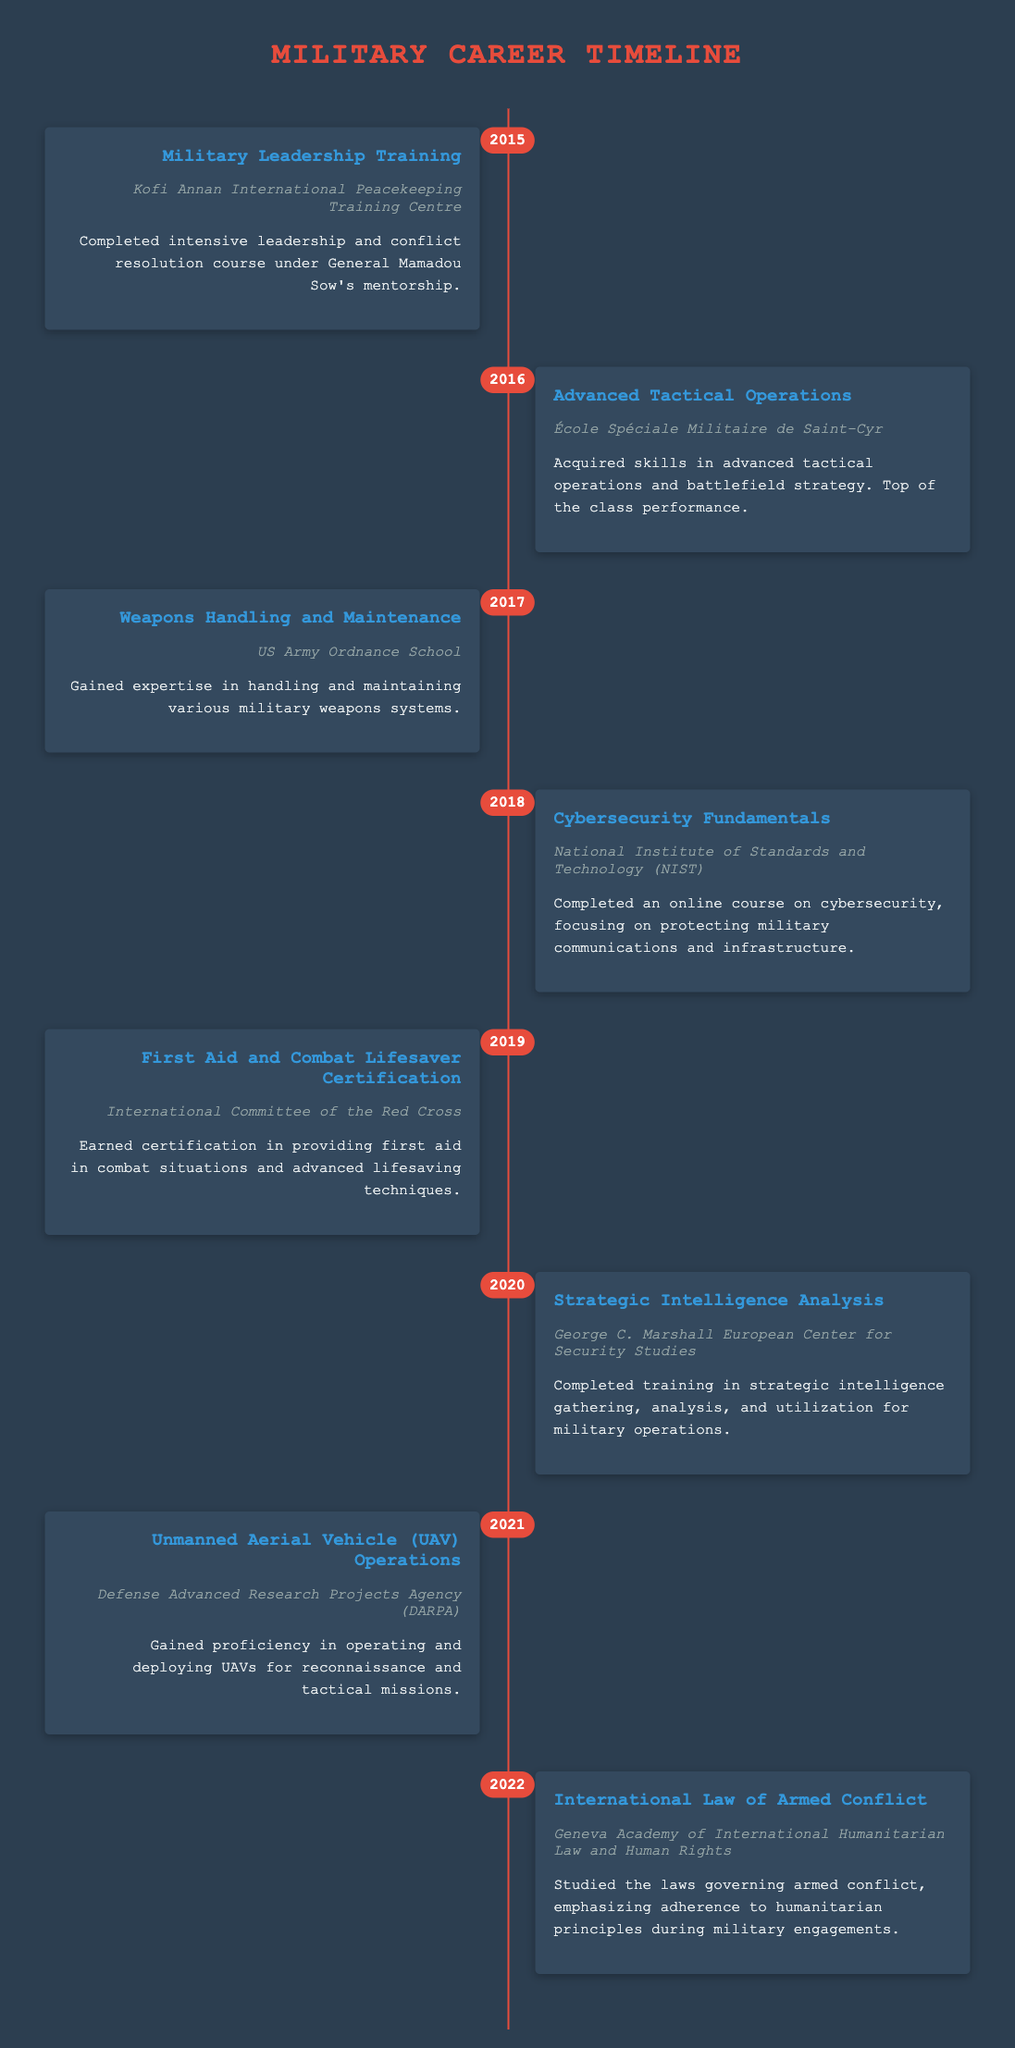What course was completed in 2015? The document states that "Military Leadership Training" was completed in 2015.
Answer: Military Leadership Training Which institution offered the "Advanced Tactical Operations" course? The course was offered by the "École Spéciale Militaire de Saint-Cyr."
Answer: École Spéciale Militaire de Saint-Cyr What year did the "Cybersecurity Fundamentals" course take place? According to the timeline, this course was completed in 2018.
Answer: 2018 In which skill area was performance stated as "Top of the class"? The document specifies that this performance refers to "Advanced Tactical Operations".
Answer: Advanced Tactical Operations What type of certification was earned from the International Committee of the Red Cross? The document mentions that the certification was "First Aid and Combat Lifesaver Certification."
Answer: First Aid and Combat Lifesaver Certification Which course focused on unmanned technology? The course that focuses on unmanned technology is "Unmanned Aerial Vehicle (UAV) Operations."
Answer: Unmanned Aerial Vehicle (UAV) Operations What is the primary focus of the course taken in 2022? The course in 2022 primarily focused on "International Law of Armed Conflict."
Answer: International Law of Armed Conflict What key skill was developed in 2020? The document indicates that the key skill developed was in "Strategic Intelligence Analysis."
Answer: Strategic Intelligence Analysis Which year marks the completion of "Weapons Handling and Maintenance"? The completion of this course is noted for the year 2017.
Answer: 2017 